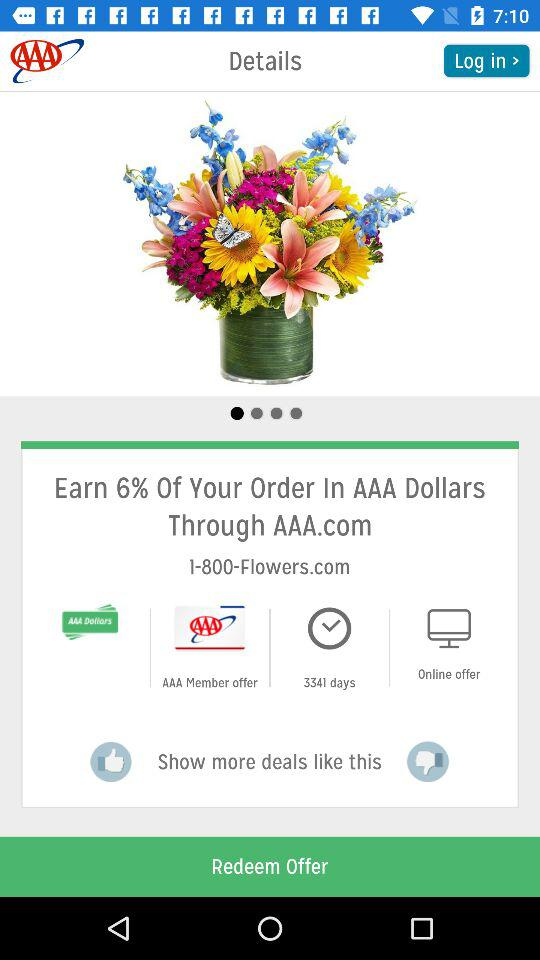How many AAA dollars will I earn if I use this offer?
Answer the question using a single word or phrase. 6% 